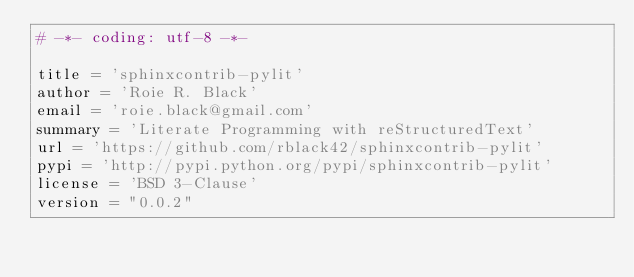Convert code to text. <code><loc_0><loc_0><loc_500><loc_500><_Python_># -*- coding: utf-8 -*-

title = 'sphinxcontrib-pylit'
author = 'Roie R. Black'
email = 'roie.black@gmail.com'
summary = 'Literate Programming with reStructuredText'
url = 'https://github.com/rblack42/sphinxcontrib-pylit'
pypi = 'http://pypi.python.org/pypi/sphinxcontrib-pylit'
license = 'BSD 3-Clause'
version = "0.0.2"
</code> 